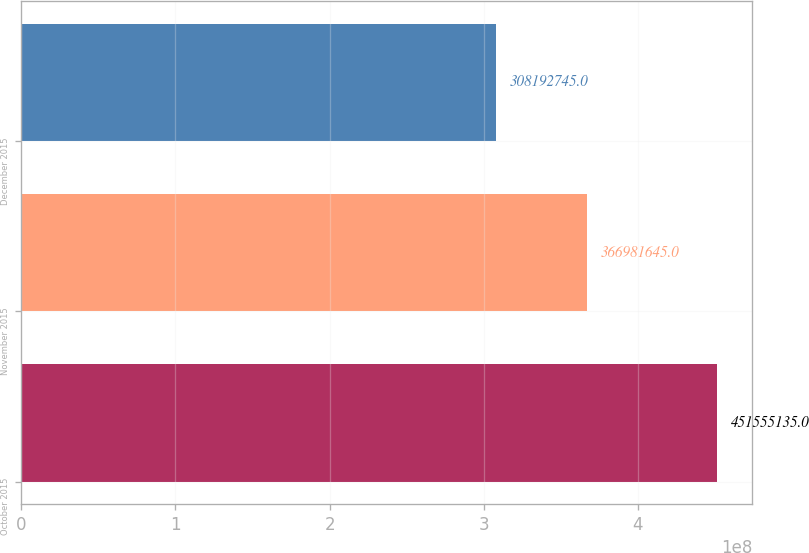Convert chart. <chart><loc_0><loc_0><loc_500><loc_500><bar_chart><fcel>October 2015<fcel>November 2015<fcel>December 2015<nl><fcel>4.51555e+08<fcel>3.66982e+08<fcel>3.08193e+08<nl></chart> 